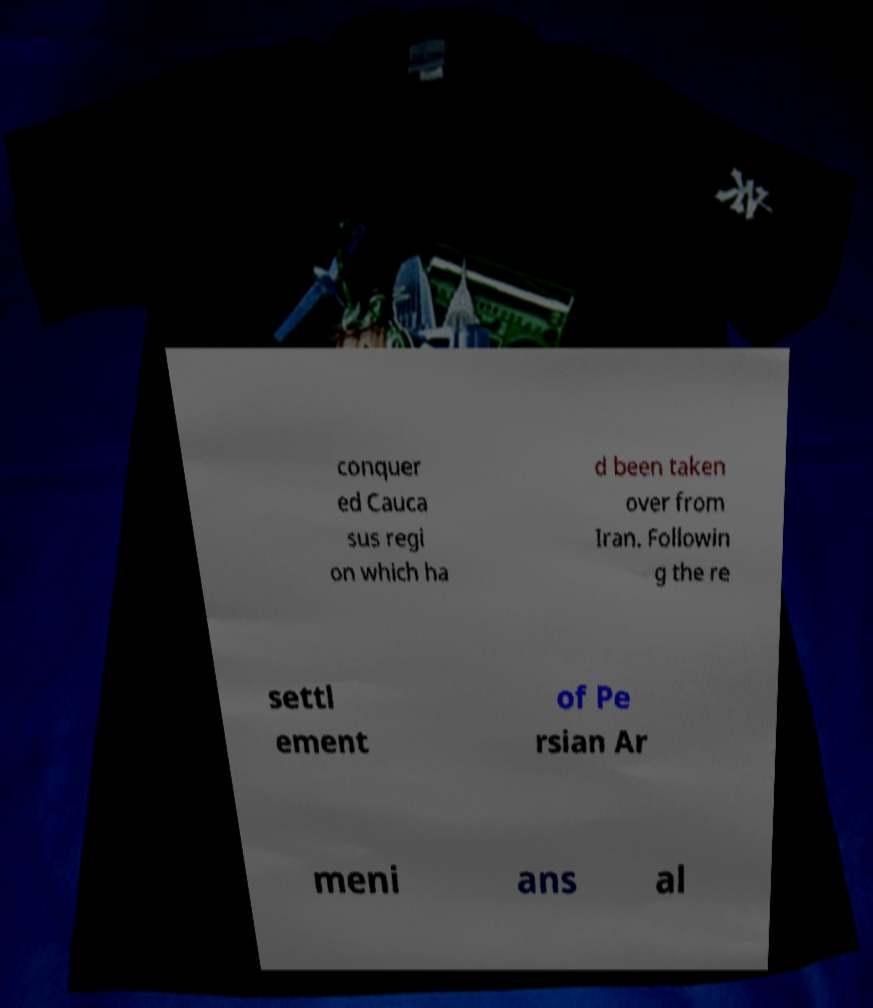Can you accurately transcribe the text from the provided image for me? conquer ed Cauca sus regi on which ha d been taken over from Iran. Followin g the re settl ement of Pe rsian Ar meni ans al 